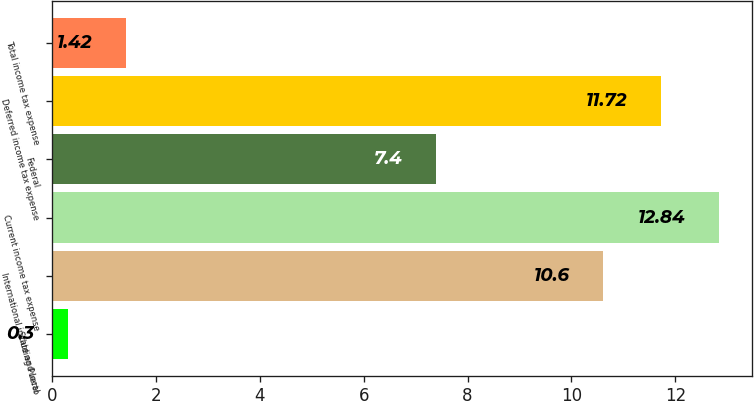Convert chart to OTSL. <chart><loc_0><loc_0><loc_500><loc_500><bar_chart><fcel>State and local<fcel>International including Puerto<fcel>Current income tax expense<fcel>Federal<fcel>Deferred income tax expense<fcel>Total income tax expense<nl><fcel>0.3<fcel>10.6<fcel>12.84<fcel>7.4<fcel>11.72<fcel>1.42<nl></chart> 